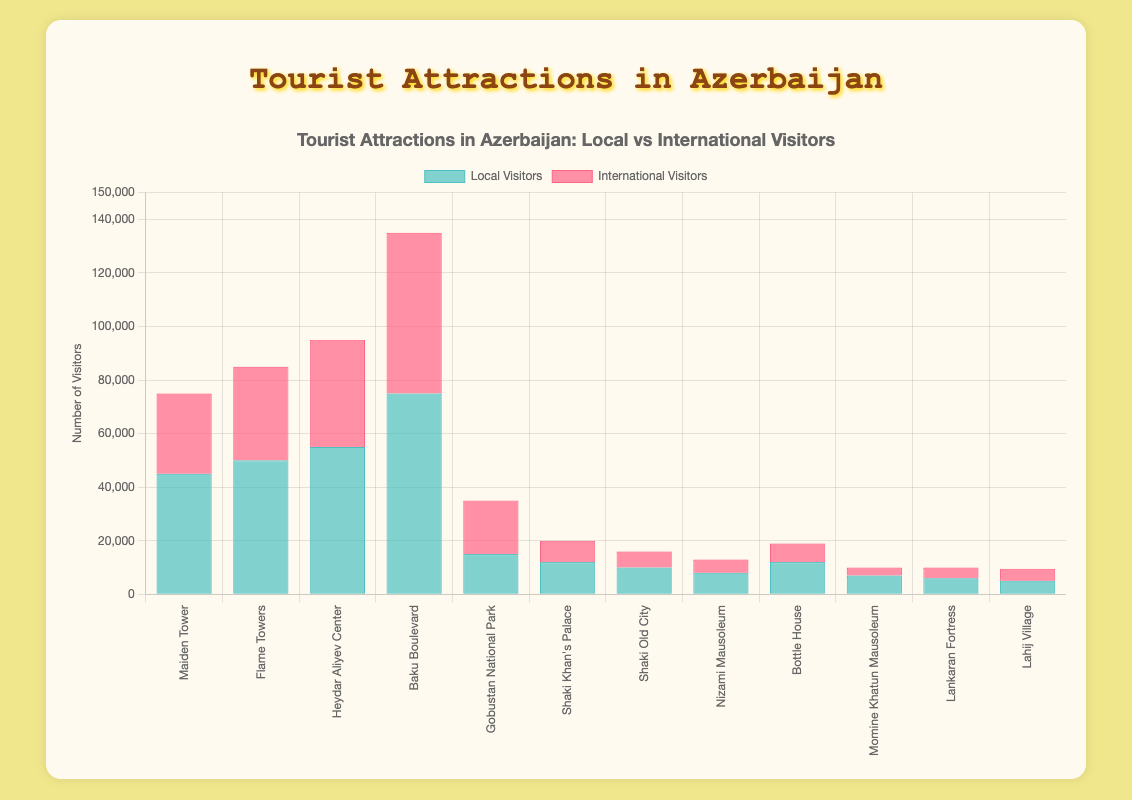Which attraction in Baku has the most visitors? By observing the heights of the bars representing each attraction in Baku, Baku Boulevard has the highest total number of visitors when you add the local and international visitors.
Answer: Baku Boulevard How does the number of local visitors to Gobustan National Park compare to the number of international visitors? The bar for local visitors to Gobustan National Park is smaller than the bar for international visitors, implying that there are fewer local visitors compared to international visitors.
Answer: Fewer local visitors What's the ratio of international to local visitors for the Heydar Aliyev Center? To find the ratio, divide the number of international visitors (40000) by the number of local visitors (55000), which simplifies to approximately 0.73.
Answer: 0.73 Which attraction has the smallest number of visitors in total? By comparing the combined height of all bars for each attraction, Lahij Village has the smallest total number of visitors (5000 locals + 4500 internationals = 9500).
Answer: Lahij Village If you sum the total visitors to both attractions in Shaki, what number do you get? Adding up the visitors for Shaki Khan's Palace (12000 locals + 8000 internationals) and Shaki Old City (10000 locals + 6000 internationals) gives 26000 + 16000, which equals 42000.
Answer: 42000 Is the number of international visitors to Flame Towers greater than the number of local visitors to Nizami Mausoleum? By comparing the bars, Flame Towers has 35000 international visitors, while Nizami Mausoleum has 8000 local visitors. Since 35000 is greater than 8000, yes.
Answer: Yes Do more tourists visit Baku or Gobustan overall? To determine this, sum the local and international visitors for all attractions in each region. Baku's total is (45000+30000) + (50000+35000) + (55000+40000) + (75000+60000) = 385000. Gobustan has (15000+20000) = 35000. Since 385000 is greater than 35000, more tourists visit Baku.
Answer: Baku What is the average number of international visitors per attraction in Baku? Adding the international visitors to the attractions in Baku: 30000, 35000, 40000, and 60000, which gives a total of 165000. Dividing this by 4 attractions gives the average: 165000 / 4 = 41250.
Answer: 41250 Compare the total visitors for Baku Boulevard and Flame Towers. Baku Boulevard's total number of visitors is (75000 locals + 60000 internationals) = 135000. For Flame Towers, the total is (50000 locals + 35000 internationals) = 85000. Baku Boulevard has more visitors than Flame Towers.
Answer: Baku Boulevard 